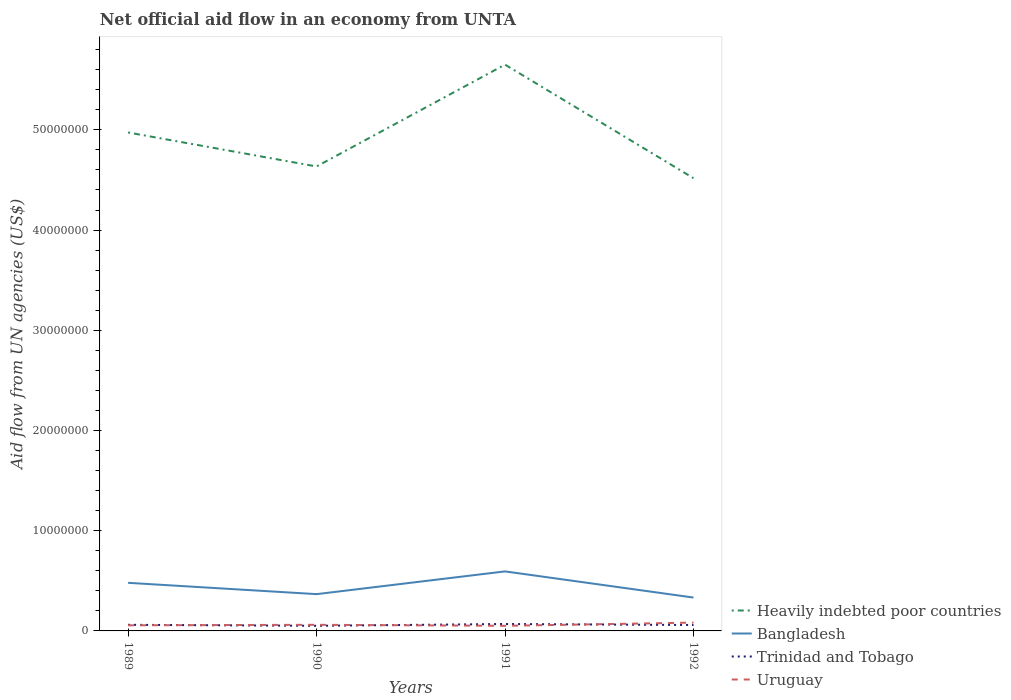How many different coloured lines are there?
Provide a succinct answer. 4. Does the line corresponding to Uruguay intersect with the line corresponding to Heavily indebted poor countries?
Offer a terse response. No. Across all years, what is the maximum net official aid flow in Bangladesh?
Provide a succinct answer. 3.33e+06. In which year was the net official aid flow in Trinidad and Tobago maximum?
Keep it short and to the point. 1990. What is the total net official aid flow in Bangladesh in the graph?
Keep it short and to the point. -2.27e+06. What is the difference between the highest and the second highest net official aid flow in Bangladesh?
Provide a short and direct response. 2.61e+06. How many years are there in the graph?
Ensure brevity in your answer.  4. Are the values on the major ticks of Y-axis written in scientific E-notation?
Offer a very short reply. No. How many legend labels are there?
Your response must be concise. 4. What is the title of the graph?
Your answer should be very brief. Net official aid flow in an economy from UNTA. Does "Sudan" appear as one of the legend labels in the graph?
Your answer should be compact. No. What is the label or title of the X-axis?
Ensure brevity in your answer.  Years. What is the label or title of the Y-axis?
Make the answer very short. Aid flow from UN agencies (US$). What is the Aid flow from UN agencies (US$) in Heavily indebted poor countries in 1989?
Provide a succinct answer. 4.97e+07. What is the Aid flow from UN agencies (US$) of Bangladesh in 1989?
Your response must be concise. 4.80e+06. What is the Aid flow from UN agencies (US$) in Uruguay in 1989?
Make the answer very short. 5.60e+05. What is the Aid flow from UN agencies (US$) in Heavily indebted poor countries in 1990?
Your answer should be compact. 4.64e+07. What is the Aid flow from UN agencies (US$) in Bangladesh in 1990?
Your answer should be very brief. 3.67e+06. What is the Aid flow from UN agencies (US$) of Trinidad and Tobago in 1990?
Keep it short and to the point. 5.10e+05. What is the Aid flow from UN agencies (US$) of Heavily indebted poor countries in 1991?
Provide a short and direct response. 5.65e+07. What is the Aid flow from UN agencies (US$) of Bangladesh in 1991?
Provide a short and direct response. 5.94e+06. What is the Aid flow from UN agencies (US$) in Trinidad and Tobago in 1991?
Your answer should be compact. 6.90e+05. What is the Aid flow from UN agencies (US$) of Uruguay in 1991?
Ensure brevity in your answer.  5.10e+05. What is the Aid flow from UN agencies (US$) of Heavily indebted poor countries in 1992?
Offer a very short reply. 4.52e+07. What is the Aid flow from UN agencies (US$) of Bangladesh in 1992?
Your answer should be very brief. 3.33e+06. What is the Aid flow from UN agencies (US$) of Trinidad and Tobago in 1992?
Ensure brevity in your answer.  5.90e+05. What is the Aid flow from UN agencies (US$) of Uruguay in 1992?
Offer a very short reply. 8.30e+05. Across all years, what is the maximum Aid flow from UN agencies (US$) of Heavily indebted poor countries?
Provide a succinct answer. 5.65e+07. Across all years, what is the maximum Aid flow from UN agencies (US$) of Bangladesh?
Offer a terse response. 5.94e+06. Across all years, what is the maximum Aid flow from UN agencies (US$) in Trinidad and Tobago?
Offer a very short reply. 6.90e+05. Across all years, what is the maximum Aid flow from UN agencies (US$) of Uruguay?
Your response must be concise. 8.30e+05. Across all years, what is the minimum Aid flow from UN agencies (US$) in Heavily indebted poor countries?
Your answer should be compact. 4.52e+07. Across all years, what is the minimum Aid flow from UN agencies (US$) of Bangladesh?
Offer a very short reply. 3.33e+06. Across all years, what is the minimum Aid flow from UN agencies (US$) of Trinidad and Tobago?
Offer a very short reply. 5.10e+05. Across all years, what is the minimum Aid flow from UN agencies (US$) in Uruguay?
Your answer should be very brief. 5.10e+05. What is the total Aid flow from UN agencies (US$) in Heavily indebted poor countries in the graph?
Ensure brevity in your answer.  1.98e+08. What is the total Aid flow from UN agencies (US$) in Bangladesh in the graph?
Your answer should be compact. 1.77e+07. What is the total Aid flow from UN agencies (US$) of Trinidad and Tobago in the graph?
Ensure brevity in your answer.  2.40e+06. What is the total Aid flow from UN agencies (US$) of Uruguay in the graph?
Offer a terse response. 2.51e+06. What is the difference between the Aid flow from UN agencies (US$) in Heavily indebted poor countries in 1989 and that in 1990?
Give a very brief answer. 3.39e+06. What is the difference between the Aid flow from UN agencies (US$) in Bangladesh in 1989 and that in 1990?
Your response must be concise. 1.13e+06. What is the difference between the Aid flow from UN agencies (US$) in Trinidad and Tobago in 1989 and that in 1990?
Your response must be concise. 1.00e+05. What is the difference between the Aid flow from UN agencies (US$) of Uruguay in 1989 and that in 1990?
Provide a short and direct response. -5.00e+04. What is the difference between the Aid flow from UN agencies (US$) in Heavily indebted poor countries in 1989 and that in 1991?
Your response must be concise. -6.77e+06. What is the difference between the Aid flow from UN agencies (US$) in Bangladesh in 1989 and that in 1991?
Your answer should be compact. -1.14e+06. What is the difference between the Aid flow from UN agencies (US$) in Trinidad and Tobago in 1989 and that in 1991?
Provide a short and direct response. -8.00e+04. What is the difference between the Aid flow from UN agencies (US$) of Heavily indebted poor countries in 1989 and that in 1992?
Make the answer very short. 4.56e+06. What is the difference between the Aid flow from UN agencies (US$) of Bangladesh in 1989 and that in 1992?
Make the answer very short. 1.47e+06. What is the difference between the Aid flow from UN agencies (US$) in Trinidad and Tobago in 1989 and that in 1992?
Your response must be concise. 2.00e+04. What is the difference between the Aid flow from UN agencies (US$) in Uruguay in 1989 and that in 1992?
Offer a terse response. -2.70e+05. What is the difference between the Aid flow from UN agencies (US$) in Heavily indebted poor countries in 1990 and that in 1991?
Your answer should be very brief. -1.02e+07. What is the difference between the Aid flow from UN agencies (US$) of Bangladesh in 1990 and that in 1991?
Your response must be concise. -2.27e+06. What is the difference between the Aid flow from UN agencies (US$) in Trinidad and Tobago in 1990 and that in 1991?
Ensure brevity in your answer.  -1.80e+05. What is the difference between the Aid flow from UN agencies (US$) of Uruguay in 1990 and that in 1991?
Provide a short and direct response. 1.00e+05. What is the difference between the Aid flow from UN agencies (US$) of Heavily indebted poor countries in 1990 and that in 1992?
Ensure brevity in your answer.  1.17e+06. What is the difference between the Aid flow from UN agencies (US$) of Bangladesh in 1990 and that in 1992?
Give a very brief answer. 3.40e+05. What is the difference between the Aid flow from UN agencies (US$) in Trinidad and Tobago in 1990 and that in 1992?
Offer a terse response. -8.00e+04. What is the difference between the Aid flow from UN agencies (US$) in Uruguay in 1990 and that in 1992?
Give a very brief answer. -2.20e+05. What is the difference between the Aid flow from UN agencies (US$) in Heavily indebted poor countries in 1991 and that in 1992?
Your answer should be very brief. 1.13e+07. What is the difference between the Aid flow from UN agencies (US$) in Bangladesh in 1991 and that in 1992?
Offer a very short reply. 2.61e+06. What is the difference between the Aid flow from UN agencies (US$) of Trinidad and Tobago in 1991 and that in 1992?
Your response must be concise. 1.00e+05. What is the difference between the Aid flow from UN agencies (US$) of Uruguay in 1991 and that in 1992?
Your answer should be compact. -3.20e+05. What is the difference between the Aid flow from UN agencies (US$) of Heavily indebted poor countries in 1989 and the Aid flow from UN agencies (US$) of Bangladesh in 1990?
Offer a very short reply. 4.61e+07. What is the difference between the Aid flow from UN agencies (US$) of Heavily indebted poor countries in 1989 and the Aid flow from UN agencies (US$) of Trinidad and Tobago in 1990?
Your answer should be compact. 4.92e+07. What is the difference between the Aid flow from UN agencies (US$) in Heavily indebted poor countries in 1989 and the Aid flow from UN agencies (US$) in Uruguay in 1990?
Keep it short and to the point. 4.91e+07. What is the difference between the Aid flow from UN agencies (US$) in Bangladesh in 1989 and the Aid flow from UN agencies (US$) in Trinidad and Tobago in 1990?
Your response must be concise. 4.29e+06. What is the difference between the Aid flow from UN agencies (US$) in Bangladesh in 1989 and the Aid flow from UN agencies (US$) in Uruguay in 1990?
Offer a very short reply. 4.19e+06. What is the difference between the Aid flow from UN agencies (US$) in Heavily indebted poor countries in 1989 and the Aid flow from UN agencies (US$) in Bangladesh in 1991?
Provide a short and direct response. 4.38e+07. What is the difference between the Aid flow from UN agencies (US$) of Heavily indebted poor countries in 1989 and the Aid flow from UN agencies (US$) of Trinidad and Tobago in 1991?
Ensure brevity in your answer.  4.90e+07. What is the difference between the Aid flow from UN agencies (US$) in Heavily indebted poor countries in 1989 and the Aid flow from UN agencies (US$) in Uruguay in 1991?
Ensure brevity in your answer.  4.92e+07. What is the difference between the Aid flow from UN agencies (US$) in Bangladesh in 1989 and the Aid flow from UN agencies (US$) in Trinidad and Tobago in 1991?
Keep it short and to the point. 4.11e+06. What is the difference between the Aid flow from UN agencies (US$) in Bangladesh in 1989 and the Aid flow from UN agencies (US$) in Uruguay in 1991?
Provide a short and direct response. 4.29e+06. What is the difference between the Aid flow from UN agencies (US$) of Trinidad and Tobago in 1989 and the Aid flow from UN agencies (US$) of Uruguay in 1991?
Keep it short and to the point. 1.00e+05. What is the difference between the Aid flow from UN agencies (US$) in Heavily indebted poor countries in 1989 and the Aid flow from UN agencies (US$) in Bangladesh in 1992?
Your response must be concise. 4.64e+07. What is the difference between the Aid flow from UN agencies (US$) of Heavily indebted poor countries in 1989 and the Aid flow from UN agencies (US$) of Trinidad and Tobago in 1992?
Provide a succinct answer. 4.92e+07. What is the difference between the Aid flow from UN agencies (US$) in Heavily indebted poor countries in 1989 and the Aid flow from UN agencies (US$) in Uruguay in 1992?
Make the answer very short. 4.89e+07. What is the difference between the Aid flow from UN agencies (US$) of Bangladesh in 1989 and the Aid flow from UN agencies (US$) of Trinidad and Tobago in 1992?
Make the answer very short. 4.21e+06. What is the difference between the Aid flow from UN agencies (US$) of Bangladesh in 1989 and the Aid flow from UN agencies (US$) of Uruguay in 1992?
Provide a short and direct response. 3.97e+06. What is the difference between the Aid flow from UN agencies (US$) of Heavily indebted poor countries in 1990 and the Aid flow from UN agencies (US$) of Bangladesh in 1991?
Make the answer very short. 4.04e+07. What is the difference between the Aid flow from UN agencies (US$) of Heavily indebted poor countries in 1990 and the Aid flow from UN agencies (US$) of Trinidad and Tobago in 1991?
Make the answer very short. 4.57e+07. What is the difference between the Aid flow from UN agencies (US$) in Heavily indebted poor countries in 1990 and the Aid flow from UN agencies (US$) in Uruguay in 1991?
Your response must be concise. 4.58e+07. What is the difference between the Aid flow from UN agencies (US$) in Bangladesh in 1990 and the Aid flow from UN agencies (US$) in Trinidad and Tobago in 1991?
Provide a succinct answer. 2.98e+06. What is the difference between the Aid flow from UN agencies (US$) in Bangladesh in 1990 and the Aid flow from UN agencies (US$) in Uruguay in 1991?
Provide a short and direct response. 3.16e+06. What is the difference between the Aid flow from UN agencies (US$) of Heavily indebted poor countries in 1990 and the Aid flow from UN agencies (US$) of Bangladesh in 1992?
Give a very brief answer. 4.30e+07. What is the difference between the Aid flow from UN agencies (US$) of Heavily indebted poor countries in 1990 and the Aid flow from UN agencies (US$) of Trinidad and Tobago in 1992?
Offer a terse response. 4.58e+07. What is the difference between the Aid flow from UN agencies (US$) of Heavily indebted poor countries in 1990 and the Aid flow from UN agencies (US$) of Uruguay in 1992?
Your answer should be compact. 4.55e+07. What is the difference between the Aid flow from UN agencies (US$) of Bangladesh in 1990 and the Aid flow from UN agencies (US$) of Trinidad and Tobago in 1992?
Offer a terse response. 3.08e+06. What is the difference between the Aid flow from UN agencies (US$) of Bangladesh in 1990 and the Aid flow from UN agencies (US$) of Uruguay in 1992?
Provide a succinct answer. 2.84e+06. What is the difference between the Aid flow from UN agencies (US$) in Trinidad and Tobago in 1990 and the Aid flow from UN agencies (US$) in Uruguay in 1992?
Your answer should be compact. -3.20e+05. What is the difference between the Aid flow from UN agencies (US$) in Heavily indebted poor countries in 1991 and the Aid flow from UN agencies (US$) in Bangladesh in 1992?
Keep it short and to the point. 5.32e+07. What is the difference between the Aid flow from UN agencies (US$) of Heavily indebted poor countries in 1991 and the Aid flow from UN agencies (US$) of Trinidad and Tobago in 1992?
Make the answer very short. 5.59e+07. What is the difference between the Aid flow from UN agencies (US$) in Heavily indebted poor countries in 1991 and the Aid flow from UN agencies (US$) in Uruguay in 1992?
Provide a succinct answer. 5.57e+07. What is the difference between the Aid flow from UN agencies (US$) in Bangladesh in 1991 and the Aid flow from UN agencies (US$) in Trinidad and Tobago in 1992?
Your answer should be very brief. 5.35e+06. What is the difference between the Aid flow from UN agencies (US$) in Bangladesh in 1991 and the Aid flow from UN agencies (US$) in Uruguay in 1992?
Ensure brevity in your answer.  5.11e+06. What is the average Aid flow from UN agencies (US$) of Heavily indebted poor countries per year?
Give a very brief answer. 4.94e+07. What is the average Aid flow from UN agencies (US$) in Bangladesh per year?
Keep it short and to the point. 4.44e+06. What is the average Aid flow from UN agencies (US$) in Trinidad and Tobago per year?
Provide a short and direct response. 6.00e+05. What is the average Aid flow from UN agencies (US$) in Uruguay per year?
Provide a short and direct response. 6.28e+05. In the year 1989, what is the difference between the Aid flow from UN agencies (US$) of Heavily indebted poor countries and Aid flow from UN agencies (US$) of Bangladesh?
Provide a short and direct response. 4.49e+07. In the year 1989, what is the difference between the Aid flow from UN agencies (US$) of Heavily indebted poor countries and Aid flow from UN agencies (US$) of Trinidad and Tobago?
Your answer should be compact. 4.91e+07. In the year 1989, what is the difference between the Aid flow from UN agencies (US$) in Heavily indebted poor countries and Aid flow from UN agencies (US$) in Uruguay?
Make the answer very short. 4.92e+07. In the year 1989, what is the difference between the Aid flow from UN agencies (US$) of Bangladesh and Aid flow from UN agencies (US$) of Trinidad and Tobago?
Your answer should be very brief. 4.19e+06. In the year 1989, what is the difference between the Aid flow from UN agencies (US$) in Bangladesh and Aid flow from UN agencies (US$) in Uruguay?
Your answer should be very brief. 4.24e+06. In the year 1989, what is the difference between the Aid flow from UN agencies (US$) of Trinidad and Tobago and Aid flow from UN agencies (US$) of Uruguay?
Provide a short and direct response. 5.00e+04. In the year 1990, what is the difference between the Aid flow from UN agencies (US$) of Heavily indebted poor countries and Aid flow from UN agencies (US$) of Bangladesh?
Your response must be concise. 4.27e+07. In the year 1990, what is the difference between the Aid flow from UN agencies (US$) of Heavily indebted poor countries and Aid flow from UN agencies (US$) of Trinidad and Tobago?
Your answer should be very brief. 4.58e+07. In the year 1990, what is the difference between the Aid flow from UN agencies (US$) in Heavily indebted poor countries and Aid flow from UN agencies (US$) in Uruguay?
Keep it short and to the point. 4.57e+07. In the year 1990, what is the difference between the Aid flow from UN agencies (US$) of Bangladesh and Aid flow from UN agencies (US$) of Trinidad and Tobago?
Keep it short and to the point. 3.16e+06. In the year 1990, what is the difference between the Aid flow from UN agencies (US$) in Bangladesh and Aid flow from UN agencies (US$) in Uruguay?
Provide a succinct answer. 3.06e+06. In the year 1991, what is the difference between the Aid flow from UN agencies (US$) in Heavily indebted poor countries and Aid flow from UN agencies (US$) in Bangladesh?
Keep it short and to the point. 5.06e+07. In the year 1991, what is the difference between the Aid flow from UN agencies (US$) in Heavily indebted poor countries and Aid flow from UN agencies (US$) in Trinidad and Tobago?
Offer a very short reply. 5.58e+07. In the year 1991, what is the difference between the Aid flow from UN agencies (US$) in Heavily indebted poor countries and Aid flow from UN agencies (US$) in Uruguay?
Offer a terse response. 5.60e+07. In the year 1991, what is the difference between the Aid flow from UN agencies (US$) in Bangladesh and Aid flow from UN agencies (US$) in Trinidad and Tobago?
Provide a short and direct response. 5.25e+06. In the year 1991, what is the difference between the Aid flow from UN agencies (US$) in Bangladesh and Aid flow from UN agencies (US$) in Uruguay?
Offer a terse response. 5.43e+06. In the year 1992, what is the difference between the Aid flow from UN agencies (US$) in Heavily indebted poor countries and Aid flow from UN agencies (US$) in Bangladesh?
Your answer should be very brief. 4.18e+07. In the year 1992, what is the difference between the Aid flow from UN agencies (US$) in Heavily indebted poor countries and Aid flow from UN agencies (US$) in Trinidad and Tobago?
Make the answer very short. 4.46e+07. In the year 1992, what is the difference between the Aid flow from UN agencies (US$) of Heavily indebted poor countries and Aid flow from UN agencies (US$) of Uruguay?
Make the answer very short. 4.44e+07. In the year 1992, what is the difference between the Aid flow from UN agencies (US$) in Bangladesh and Aid flow from UN agencies (US$) in Trinidad and Tobago?
Offer a terse response. 2.74e+06. In the year 1992, what is the difference between the Aid flow from UN agencies (US$) in Bangladesh and Aid flow from UN agencies (US$) in Uruguay?
Your response must be concise. 2.50e+06. What is the ratio of the Aid flow from UN agencies (US$) of Heavily indebted poor countries in 1989 to that in 1990?
Your answer should be compact. 1.07. What is the ratio of the Aid flow from UN agencies (US$) of Bangladesh in 1989 to that in 1990?
Offer a terse response. 1.31. What is the ratio of the Aid flow from UN agencies (US$) in Trinidad and Tobago in 1989 to that in 1990?
Your answer should be very brief. 1.2. What is the ratio of the Aid flow from UN agencies (US$) in Uruguay in 1989 to that in 1990?
Offer a very short reply. 0.92. What is the ratio of the Aid flow from UN agencies (US$) of Heavily indebted poor countries in 1989 to that in 1991?
Keep it short and to the point. 0.88. What is the ratio of the Aid flow from UN agencies (US$) of Bangladesh in 1989 to that in 1991?
Your response must be concise. 0.81. What is the ratio of the Aid flow from UN agencies (US$) of Trinidad and Tobago in 1989 to that in 1991?
Provide a succinct answer. 0.88. What is the ratio of the Aid flow from UN agencies (US$) in Uruguay in 1989 to that in 1991?
Ensure brevity in your answer.  1.1. What is the ratio of the Aid flow from UN agencies (US$) in Heavily indebted poor countries in 1989 to that in 1992?
Your answer should be very brief. 1.1. What is the ratio of the Aid flow from UN agencies (US$) in Bangladesh in 1989 to that in 1992?
Your answer should be very brief. 1.44. What is the ratio of the Aid flow from UN agencies (US$) of Trinidad and Tobago in 1989 to that in 1992?
Your answer should be very brief. 1.03. What is the ratio of the Aid flow from UN agencies (US$) in Uruguay in 1989 to that in 1992?
Your answer should be compact. 0.67. What is the ratio of the Aid flow from UN agencies (US$) of Heavily indebted poor countries in 1990 to that in 1991?
Your answer should be very brief. 0.82. What is the ratio of the Aid flow from UN agencies (US$) of Bangladesh in 1990 to that in 1991?
Make the answer very short. 0.62. What is the ratio of the Aid flow from UN agencies (US$) of Trinidad and Tobago in 1990 to that in 1991?
Your response must be concise. 0.74. What is the ratio of the Aid flow from UN agencies (US$) in Uruguay in 1990 to that in 1991?
Provide a succinct answer. 1.2. What is the ratio of the Aid flow from UN agencies (US$) in Heavily indebted poor countries in 1990 to that in 1992?
Offer a terse response. 1.03. What is the ratio of the Aid flow from UN agencies (US$) in Bangladesh in 1990 to that in 1992?
Your response must be concise. 1.1. What is the ratio of the Aid flow from UN agencies (US$) in Trinidad and Tobago in 1990 to that in 1992?
Keep it short and to the point. 0.86. What is the ratio of the Aid flow from UN agencies (US$) of Uruguay in 1990 to that in 1992?
Offer a terse response. 0.73. What is the ratio of the Aid flow from UN agencies (US$) of Heavily indebted poor countries in 1991 to that in 1992?
Your response must be concise. 1.25. What is the ratio of the Aid flow from UN agencies (US$) in Bangladesh in 1991 to that in 1992?
Make the answer very short. 1.78. What is the ratio of the Aid flow from UN agencies (US$) of Trinidad and Tobago in 1991 to that in 1992?
Ensure brevity in your answer.  1.17. What is the ratio of the Aid flow from UN agencies (US$) of Uruguay in 1991 to that in 1992?
Provide a succinct answer. 0.61. What is the difference between the highest and the second highest Aid flow from UN agencies (US$) of Heavily indebted poor countries?
Offer a very short reply. 6.77e+06. What is the difference between the highest and the second highest Aid flow from UN agencies (US$) in Bangladesh?
Offer a very short reply. 1.14e+06. What is the difference between the highest and the second highest Aid flow from UN agencies (US$) of Trinidad and Tobago?
Provide a succinct answer. 8.00e+04. What is the difference between the highest and the second highest Aid flow from UN agencies (US$) in Uruguay?
Make the answer very short. 2.20e+05. What is the difference between the highest and the lowest Aid flow from UN agencies (US$) in Heavily indebted poor countries?
Provide a short and direct response. 1.13e+07. What is the difference between the highest and the lowest Aid flow from UN agencies (US$) in Bangladesh?
Provide a short and direct response. 2.61e+06. What is the difference between the highest and the lowest Aid flow from UN agencies (US$) in Trinidad and Tobago?
Provide a short and direct response. 1.80e+05. 